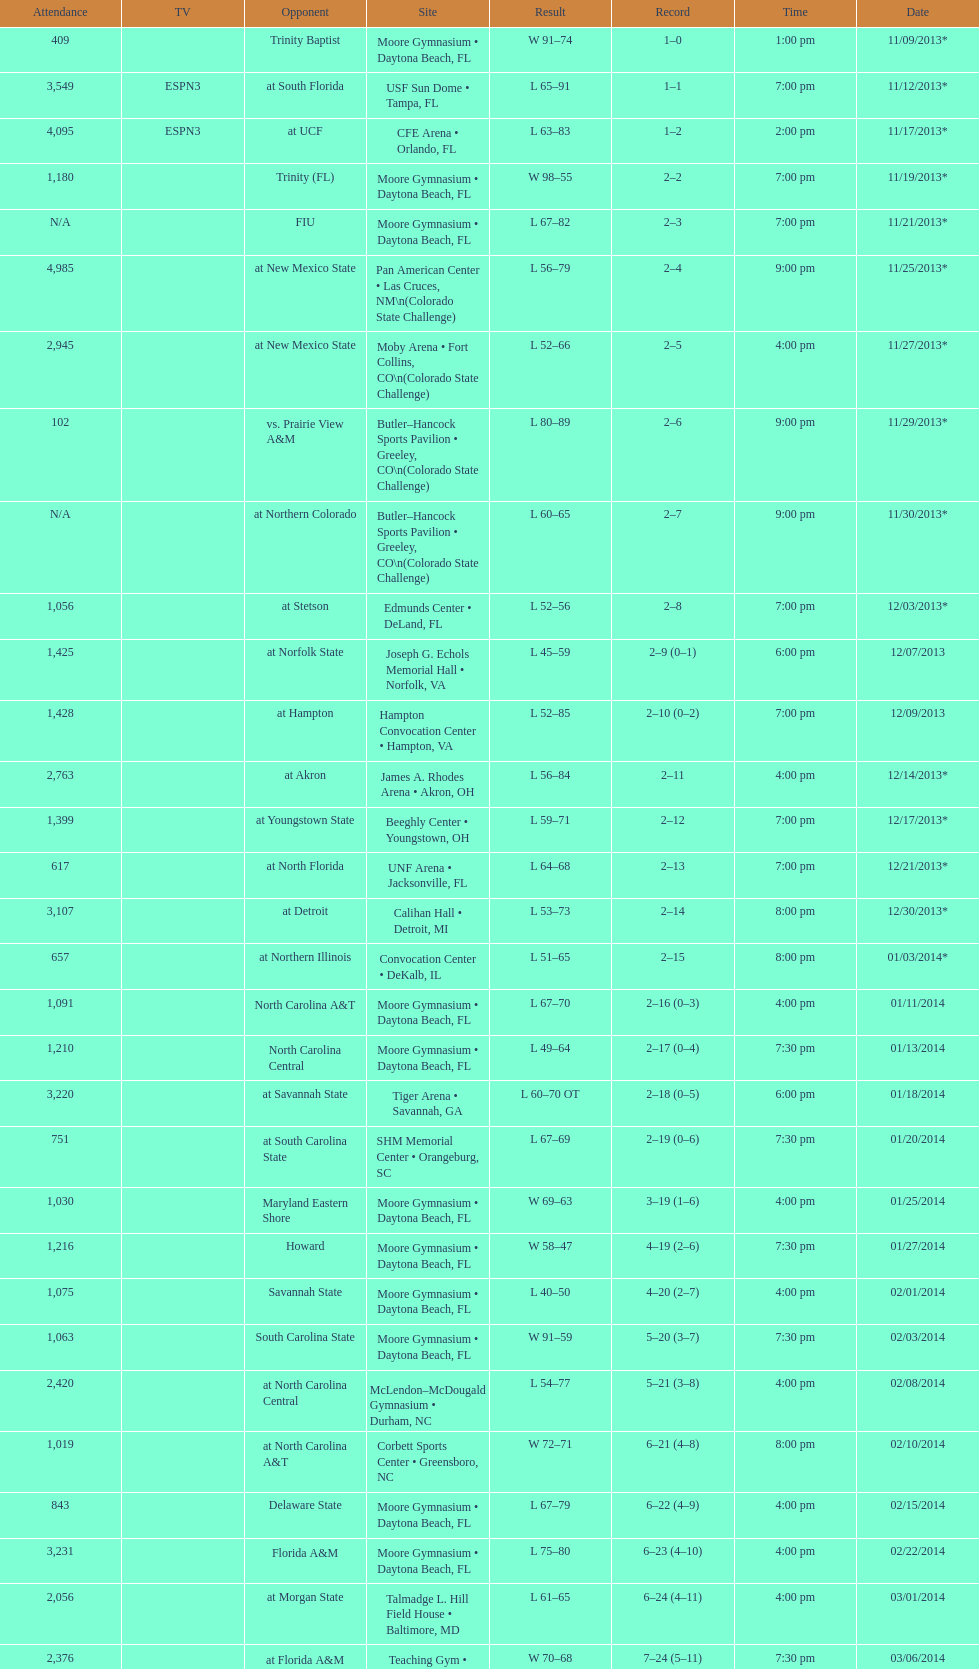Was the attendance of the game held on 11/19/2013 greater than 1,000? Yes. 